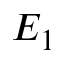Convert formula to latex. <formula><loc_0><loc_0><loc_500><loc_500>E _ { 1 }</formula> 